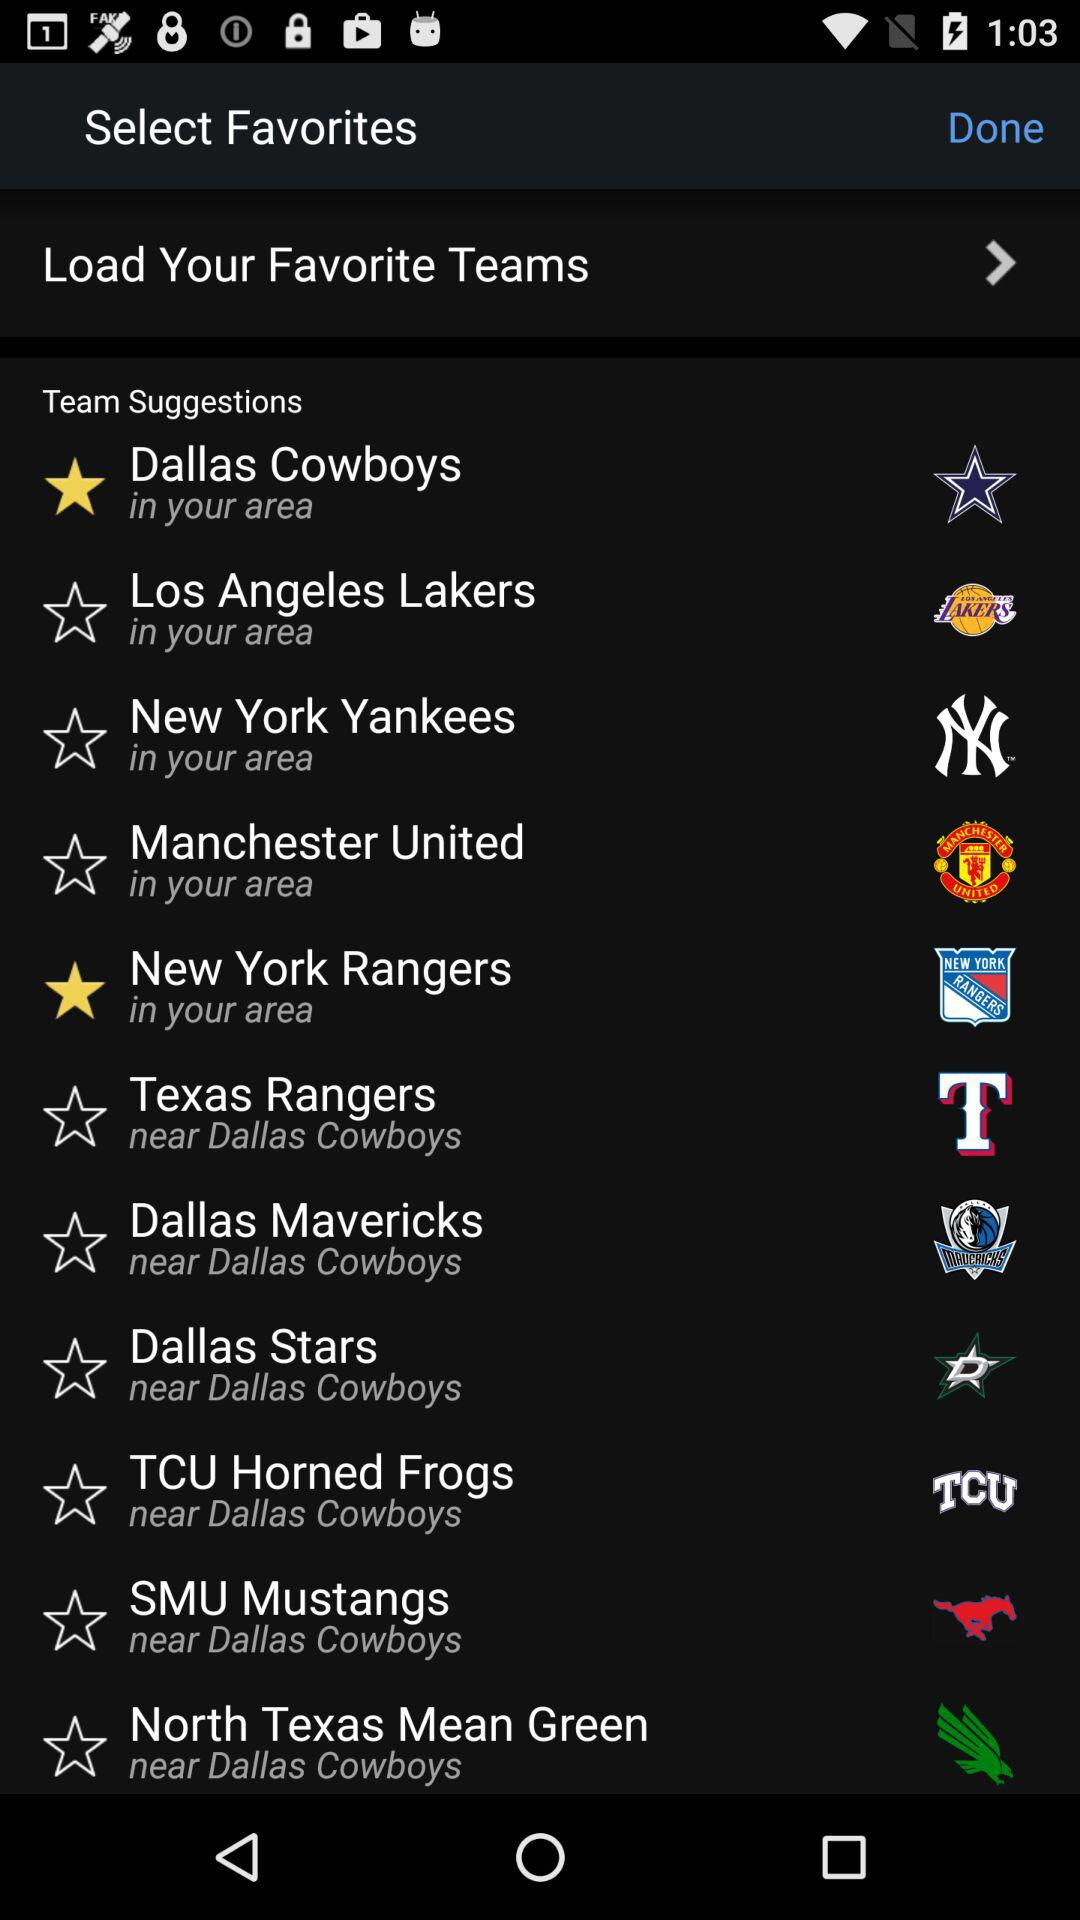Which teams are selected as favorites? The selected teams are "Dallas Cowboys" and "New York Rangers". 